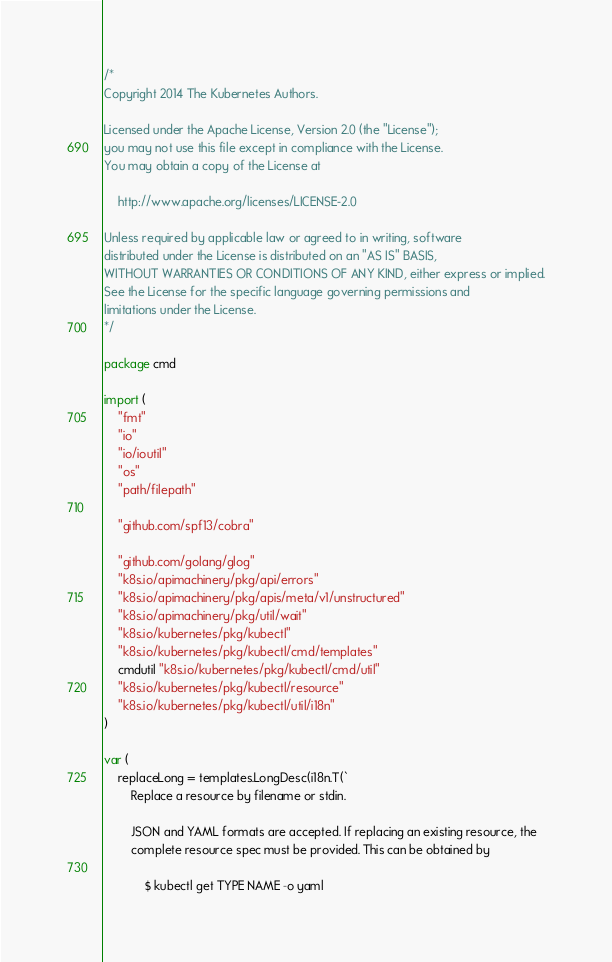<code> <loc_0><loc_0><loc_500><loc_500><_Go_>/*
Copyright 2014 The Kubernetes Authors.

Licensed under the Apache License, Version 2.0 (the "License");
you may not use this file except in compliance with the License.
You may obtain a copy of the License at

    http://www.apache.org/licenses/LICENSE-2.0

Unless required by applicable law or agreed to in writing, software
distributed under the License is distributed on an "AS IS" BASIS,
WITHOUT WARRANTIES OR CONDITIONS OF ANY KIND, either express or implied.
See the License for the specific language governing permissions and
limitations under the License.
*/

package cmd

import (
	"fmt"
	"io"
	"io/ioutil"
	"os"
	"path/filepath"

	"github.com/spf13/cobra"

	"github.com/golang/glog"
	"k8s.io/apimachinery/pkg/api/errors"
	"k8s.io/apimachinery/pkg/apis/meta/v1/unstructured"
	"k8s.io/apimachinery/pkg/util/wait"
	"k8s.io/kubernetes/pkg/kubectl"
	"k8s.io/kubernetes/pkg/kubectl/cmd/templates"
	cmdutil "k8s.io/kubernetes/pkg/kubectl/cmd/util"
	"k8s.io/kubernetes/pkg/kubectl/resource"
	"k8s.io/kubernetes/pkg/kubectl/util/i18n"
)

var (
	replaceLong = templates.LongDesc(i18n.T(`
		Replace a resource by filename or stdin.

		JSON and YAML formats are accepted. If replacing an existing resource, the
		complete resource spec must be provided. This can be obtained by

		    $ kubectl get TYPE NAME -o yaml
</code> 